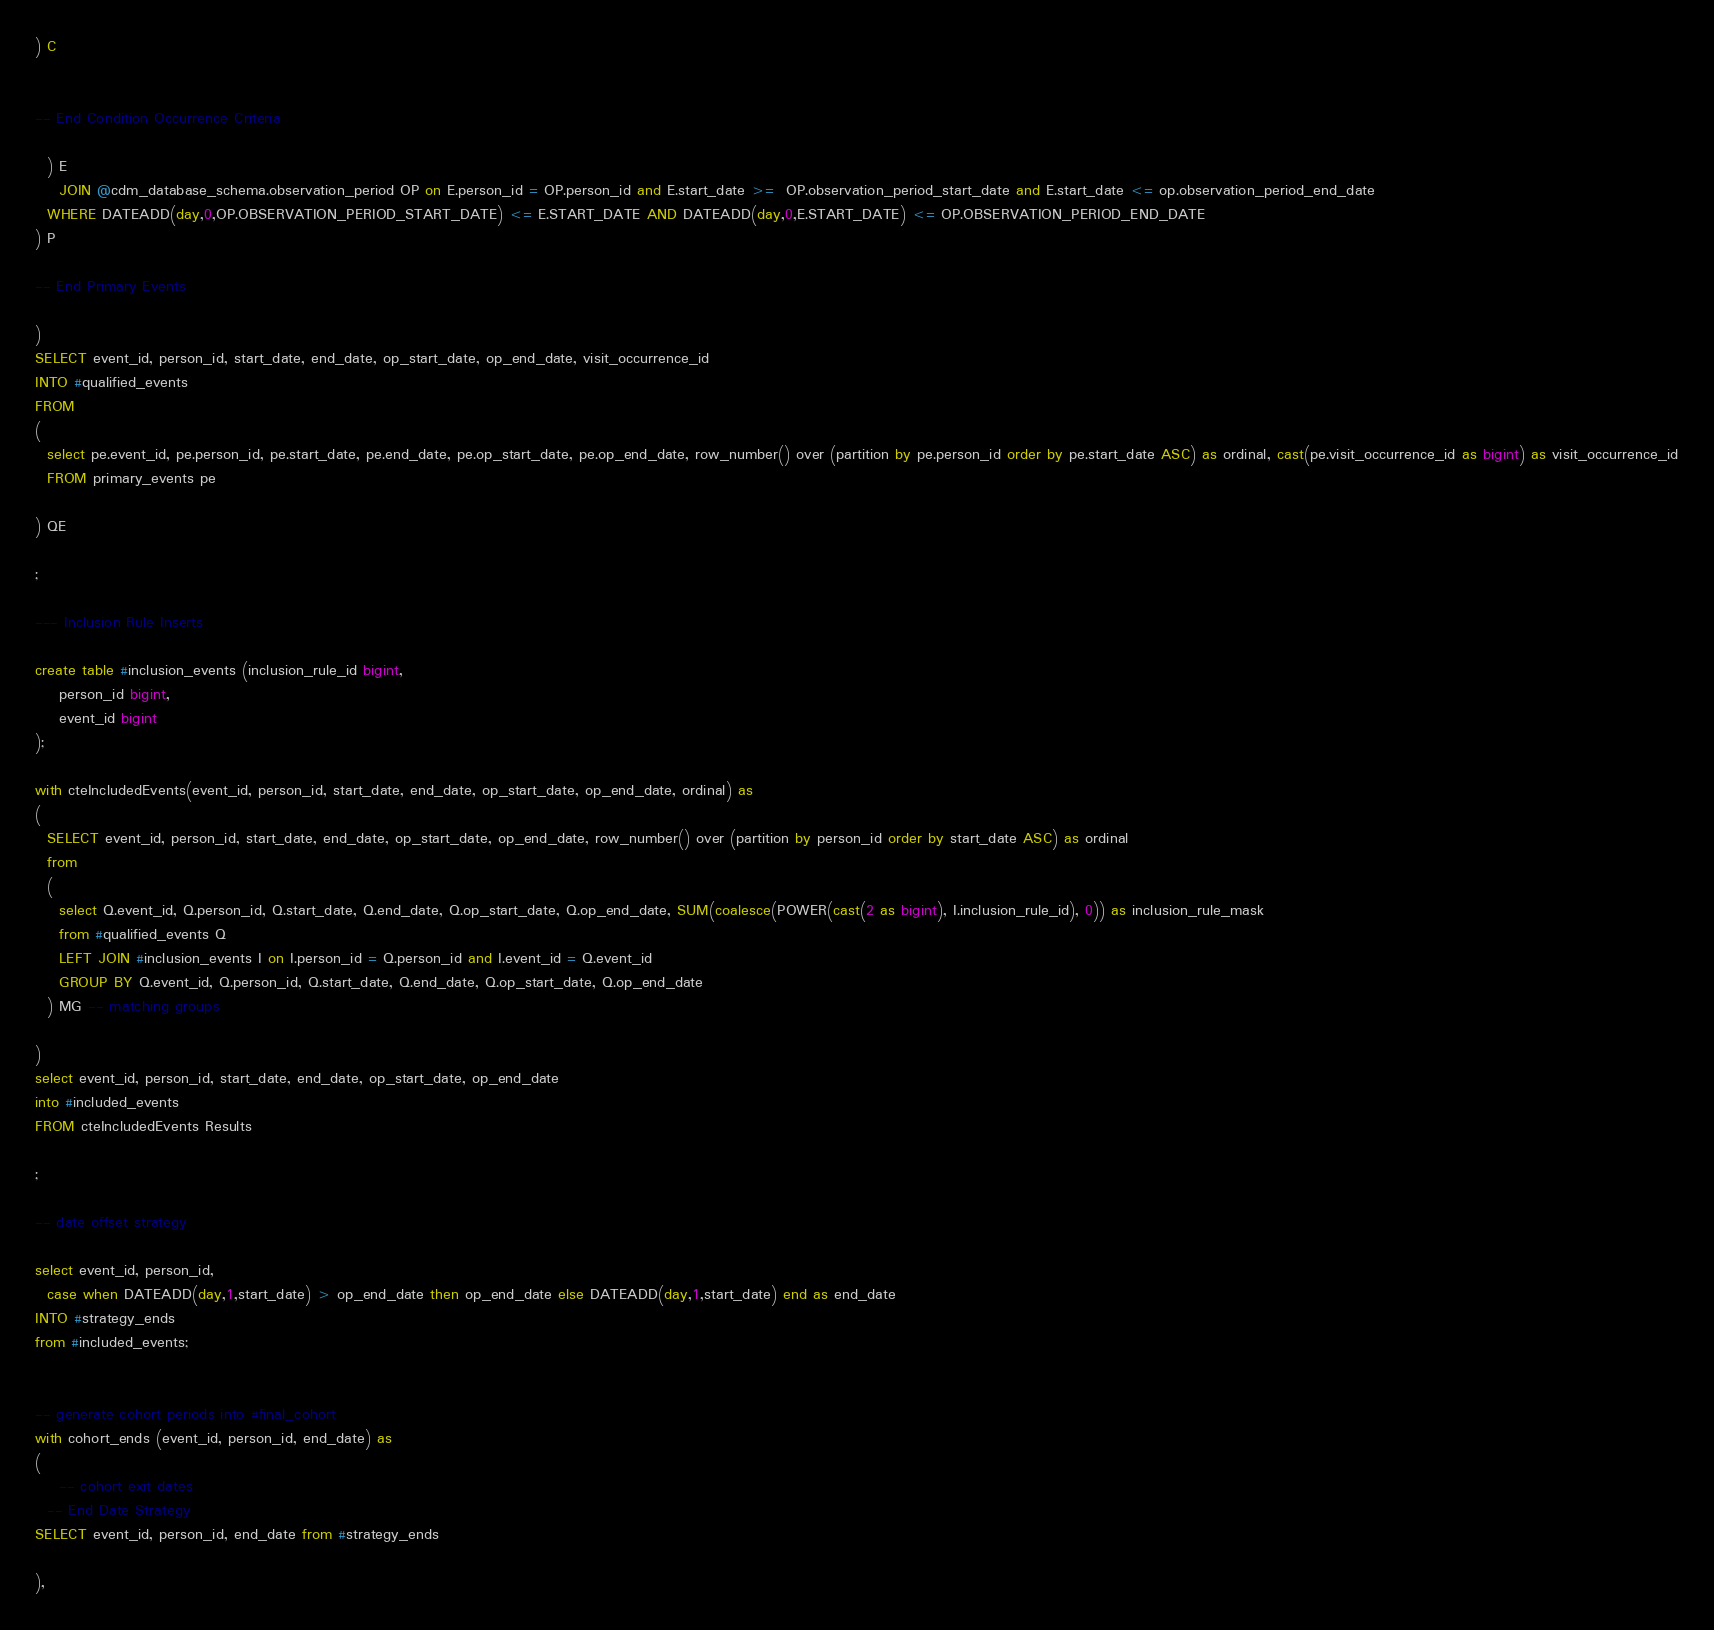Convert code to text. <code><loc_0><loc_0><loc_500><loc_500><_SQL_>) C


-- End Condition Occurrence Criteria

  ) E
	JOIN @cdm_database_schema.observation_period OP on E.person_id = OP.person_id and E.start_date >=  OP.observation_period_start_date and E.start_date <= op.observation_period_end_date
  WHERE DATEADD(day,0,OP.OBSERVATION_PERIOD_START_DATE) <= E.START_DATE AND DATEADD(day,0,E.START_DATE) <= OP.OBSERVATION_PERIOD_END_DATE
) P

-- End Primary Events

)
SELECT event_id, person_id, start_date, end_date, op_start_date, op_end_date, visit_occurrence_id
INTO #qualified_events
FROM 
(
  select pe.event_id, pe.person_id, pe.start_date, pe.end_date, pe.op_start_date, pe.op_end_date, row_number() over (partition by pe.person_id order by pe.start_date ASC) as ordinal, cast(pe.visit_occurrence_id as bigint) as visit_occurrence_id
  FROM primary_events pe
  
) QE

;

--- Inclusion Rule Inserts

create table #inclusion_events (inclusion_rule_id bigint,
	person_id bigint,
	event_id bigint
);

with cteIncludedEvents(event_id, person_id, start_date, end_date, op_start_date, op_end_date, ordinal) as
(
  SELECT event_id, person_id, start_date, end_date, op_start_date, op_end_date, row_number() over (partition by person_id order by start_date ASC) as ordinal
  from
  (
    select Q.event_id, Q.person_id, Q.start_date, Q.end_date, Q.op_start_date, Q.op_end_date, SUM(coalesce(POWER(cast(2 as bigint), I.inclusion_rule_id), 0)) as inclusion_rule_mask
    from #qualified_events Q
    LEFT JOIN #inclusion_events I on I.person_id = Q.person_id and I.event_id = Q.event_id
    GROUP BY Q.event_id, Q.person_id, Q.start_date, Q.end_date, Q.op_start_date, Q.op_end_date
  ) MG -- matching groups

)
select event_id, person_id, start_date, end_date, op_start_date, op_end_date
into #included_events
FROM cteIncludedEvents Results

;

-- date offset strategy

select event_id, person_id, 
  case when DATEADD(day,1,start_date) > op_end_date then op_end_date else DATEADD(day,1,start_date) end as end_date
INTO #strategy_ends
from #included_events;


-- generate cohort periods into #final_cohort
with cohort_ends (event_id, person_id, end_date) as
(
	-- cohort exit dates
  -- End Date Strategy
SELECT event_id, person_id, end_date from #strategy_ends

),</code> 